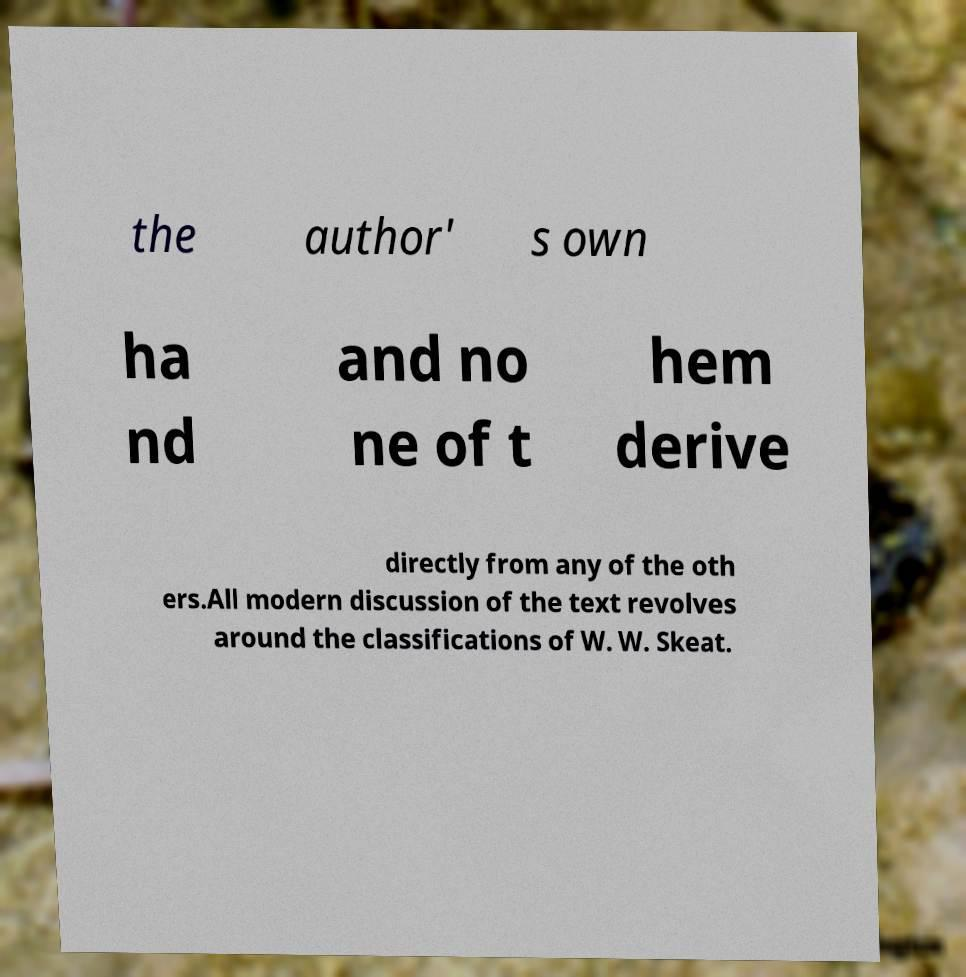Could you assist in decoding the text presented in this image and type it out clearly? the author' s own ha nd and no ne of t hem derive directly from any of the oth ers.All modern discussion of the text revolves around the classifications of W. W. Skeat. 